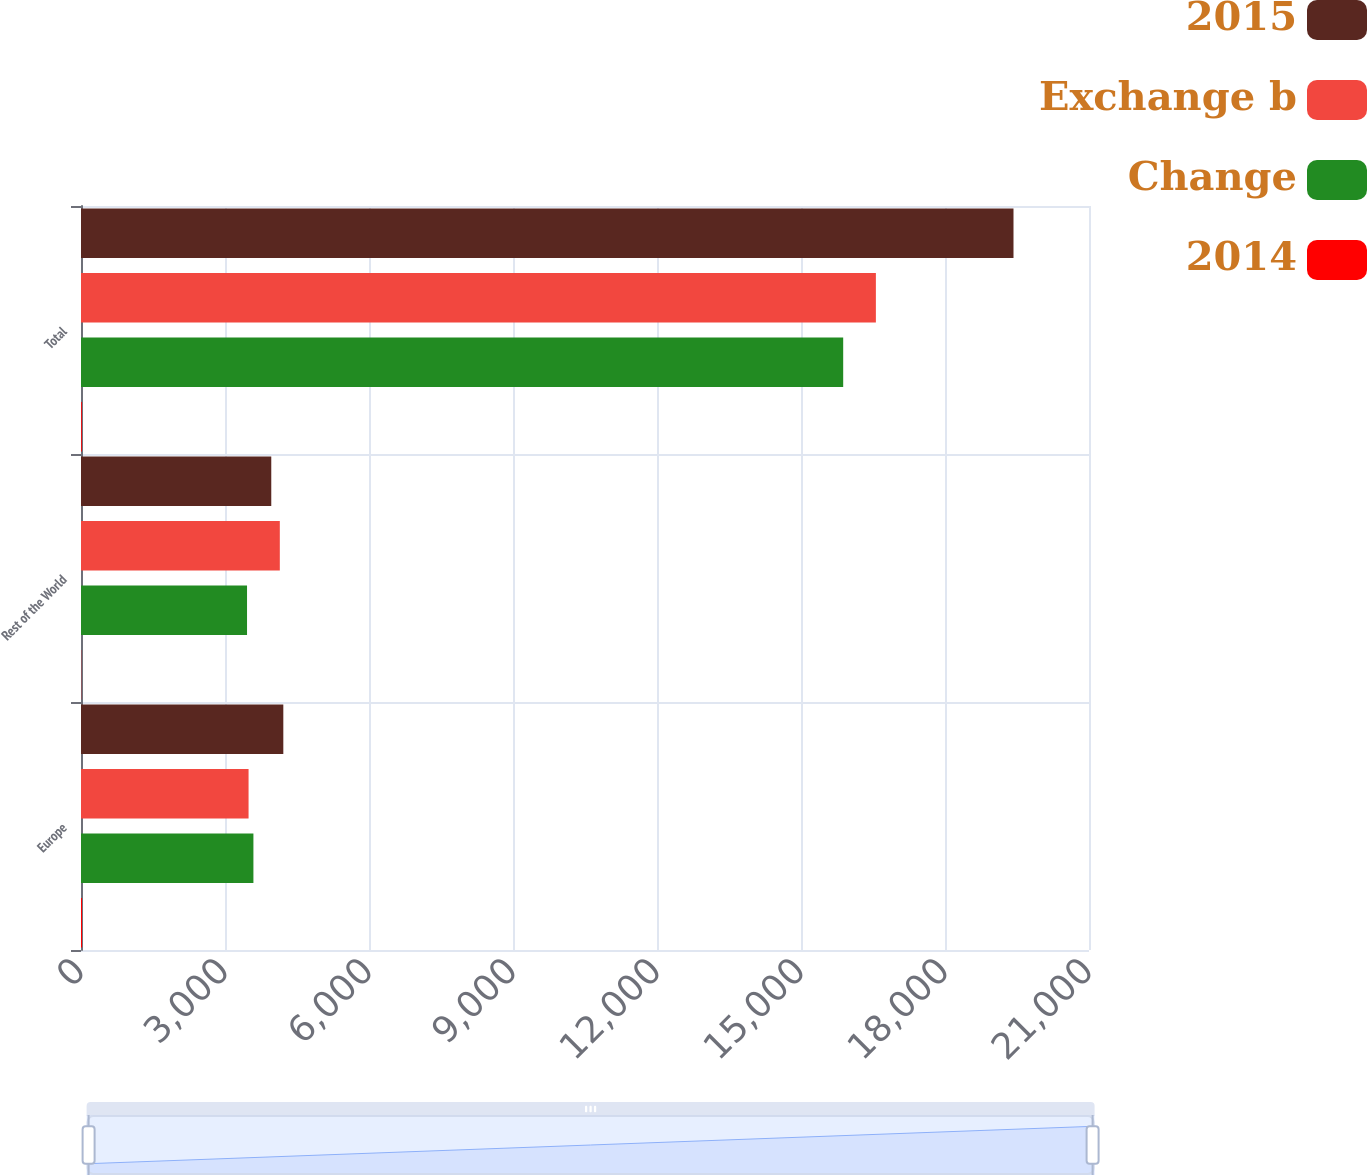Convert chart. <chart><loc_0><loc_0><loc_500><loc_500><stacked_bar_chart><ecel><fcel>Europe<fcel>Rest of the World<fcel>Total<nl><fcel>2015<fcel>4215<fcel>3964<fcel>19427<nl><fcel>Exchange b<fcel>3491<fcel>4142<fcel>16560<nl><fcel>Change<fcel>3592<fcel>3459<fcel>15879<nl><fcel>2014<fcel>21<fcel>4<fcel>17<nl></chart> 